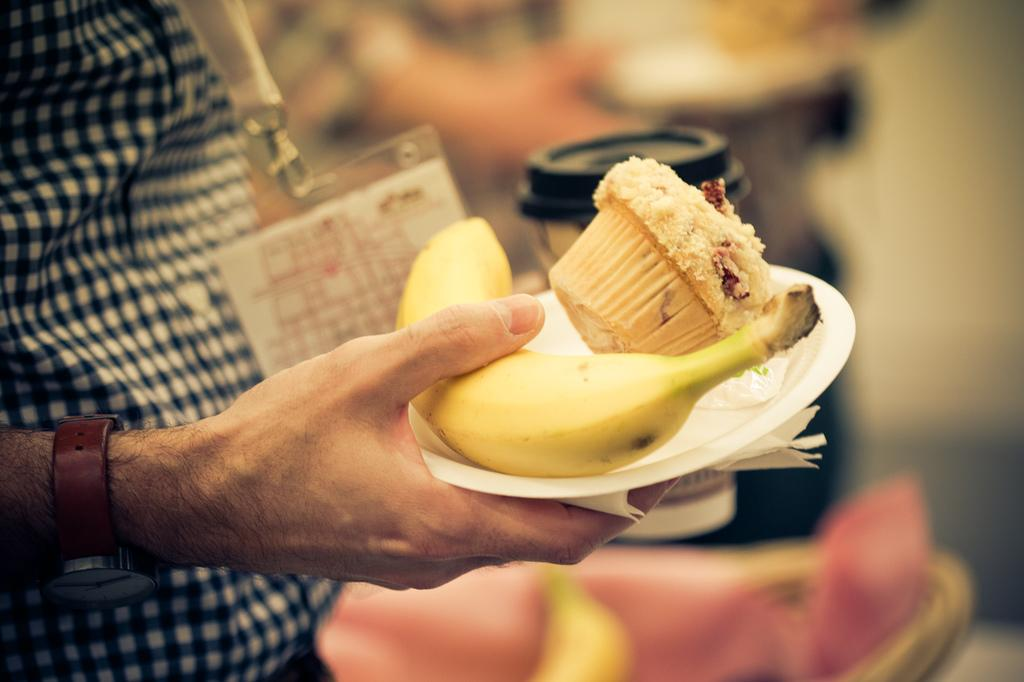What is the main subject of the image? There is a person in the image. What is the person doing in the image? The person is holding food items. Can you describe any additional items the person is wearing or carrying? The person is wearing an identity card. What type of dog can be seen playing with the food items in the image? There is no dog visible in the image, and the food items are being held by the person. 